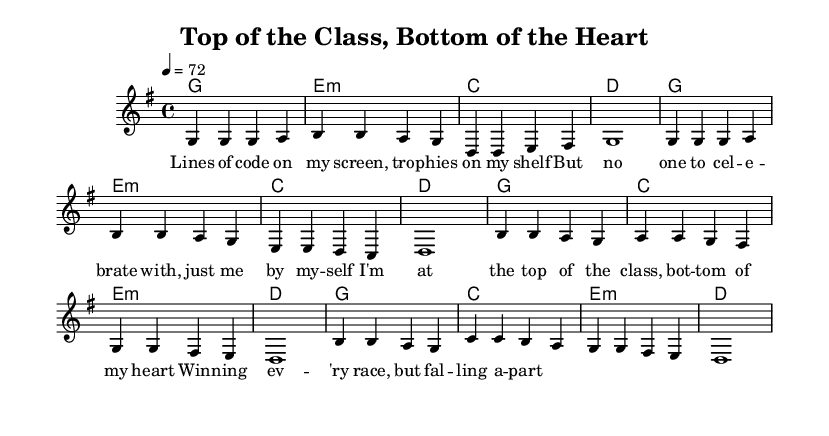What is the key signature of this music? The key signature is G major, which has one sharp (F#). This can be identified by looking at the key signature at the beginning of the score.
Answer: G major What is the time signature of this music? The time signature is 4/4, which means there are four beats in each measure and the quarter note gets one beat. This is indicated at the beginning of the score in the time signature notation.
Answer: 4/4 What is the tempo marking for this piece? The tempo is marked as 4 = 72, indicating that there are 72 beats per minute. This is located above the staff in the score under the tempo marking.
Answer: 72 How many measures are in the melody section? The melody section has a total of 8 measures, as counted by looking at the bar lines in the melody part. The verses and chorus are structured into separate measures, making the count straightforward.
Answer: 8 What is the first line of the lyrics? The first line of the lyrics is "Lines of code on my screen, tro -- phies on my shelf." This can be easily found by reading the lyric text directly above the corresponding melody notes.
Answer: Lines of code on my screen, tro -- phies on my shelf Which chord is used in the second measure? The chord used in the second measure is E minor, as indicated by the chord symbols written above that measure. This requires looking at the chord changes that correspond to each measure in the score.
Answer: E minor What is the emotional theme explored in this ballad? The theme explores loneliness despite success and high achievement, as suggested by the lyrics expressing feelings of being at the "top of the class" yet "bottom of my heart." This can be concluded by analyzing the lyrics and their corresponding emotions.
Answer: Loneliness 